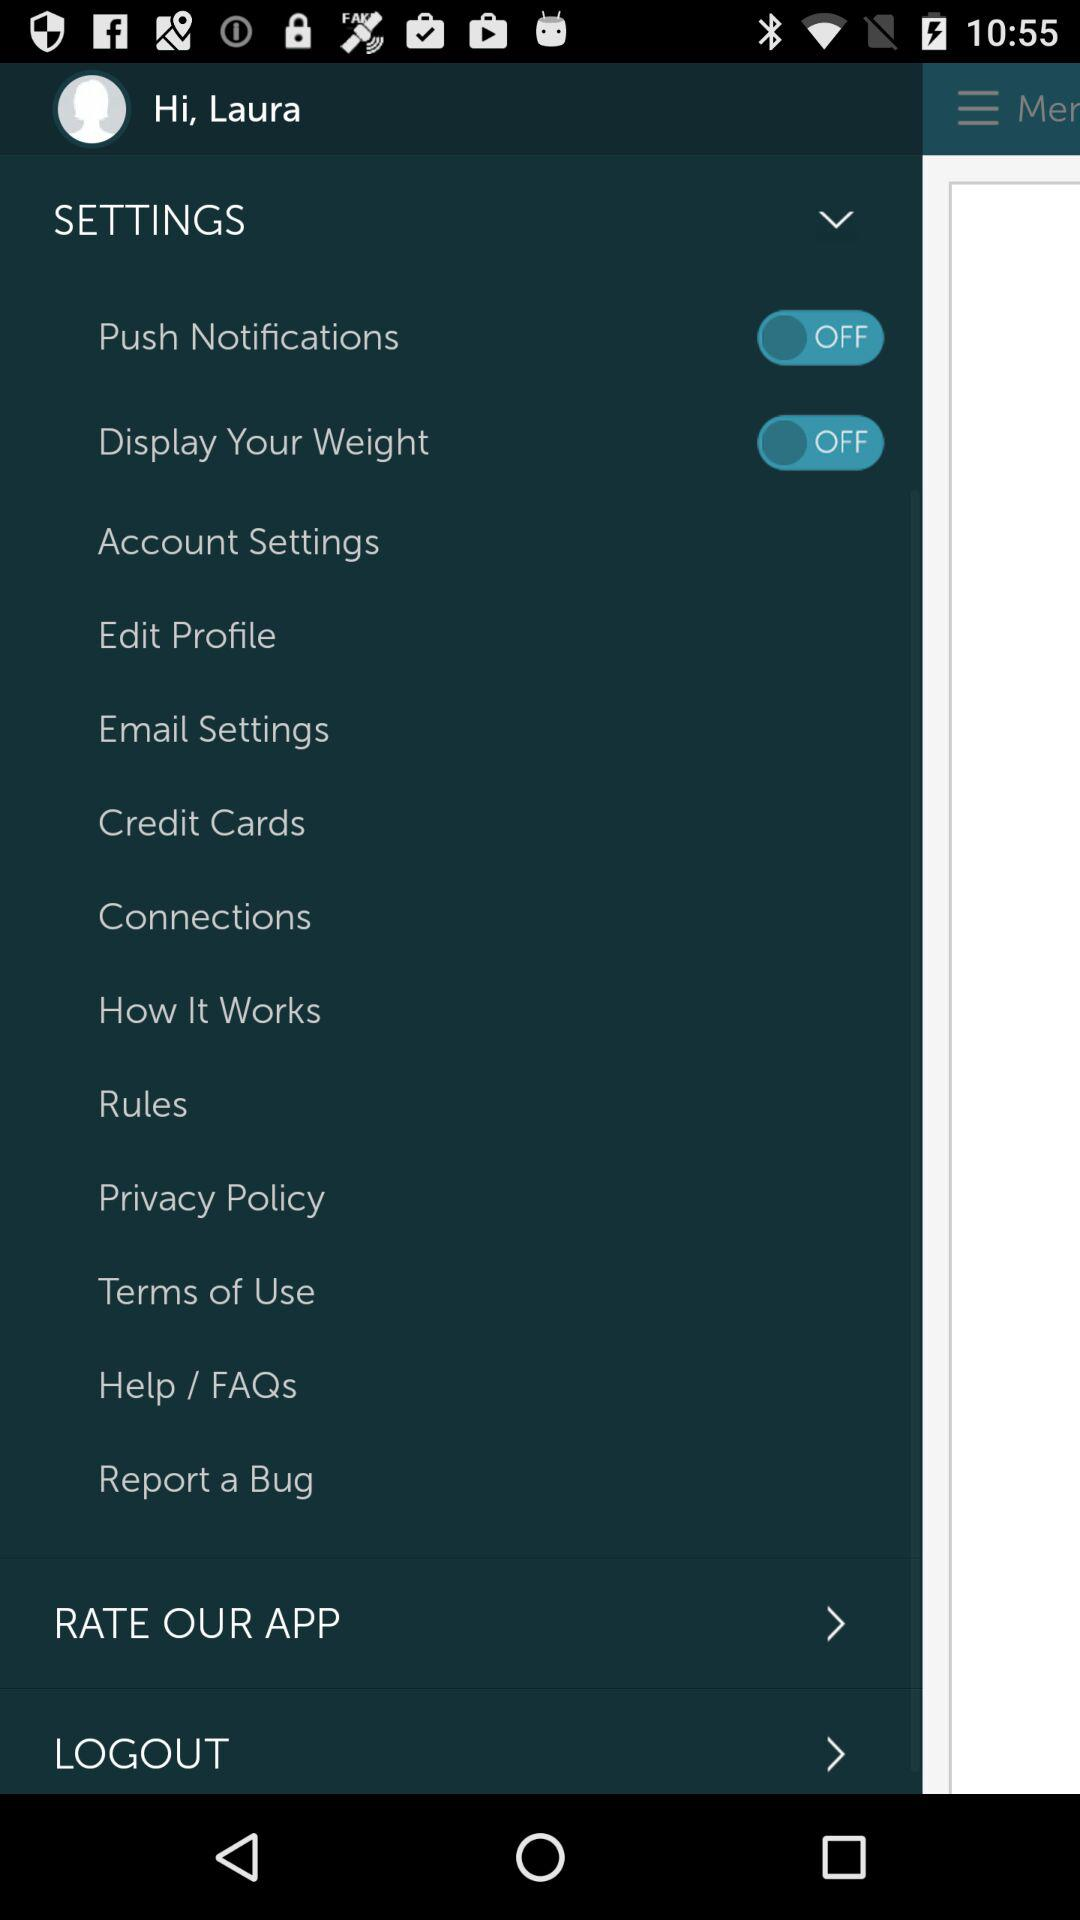What is the current status of "Display Your Weight"? The current status of "Display Your Weight" is "off". 